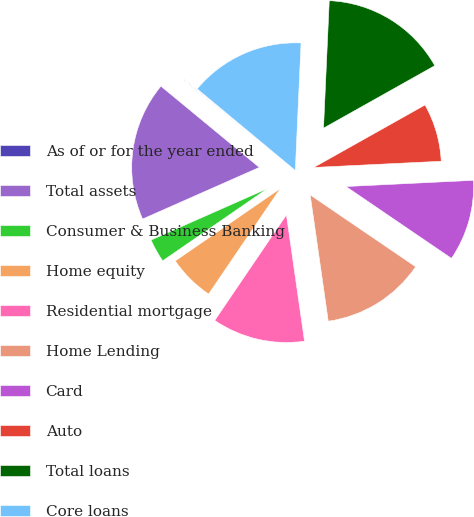Convert chart. <chart><loc_0><loc_0><loc_500><loc_500><pie_chart><fcel>As of or for the year ended<fcel>Total assets<fcel>Consumer & Business Banking<fcel>Home equity<fcel>Residential mortgage<fcel>Home Lending<fcel>Card<fcel>Auto<fcel>Total loans<fcel>Core loans<nl><fcel>0.05%<fcel>17.61%<fcel>2.98%<fcel>5.9%<fcel>11.76%<fcel>13.22%<fcel>10.29%<fcel>7.37%<fcel>16.14%<fcel>14.68%<nl></chart> 